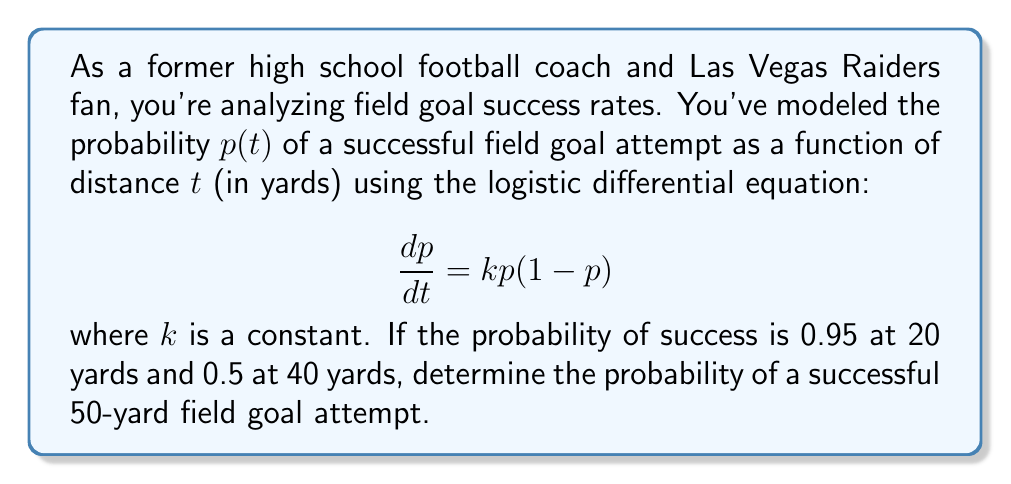Can you solve this math problem? Let's solve this step-by-step:

1) The general solution to the logistic differential equation is:

   $$p(t) = \frac{1}{1 + Ce^{-kt}}$$

2) We need to find $k$ and $C$ using the given conditions:

   At $t=20$, $p(20) = 0.95$
   At $t=40$, $p(40) = 0.5$

3) Using the condition at $t=40$:

   $$0.5 = \frac{1}{1 + Ce^{-40k}}$$

   This simplifies to $Ce^{-40k} = 1$

4) Using the condition at $t=20$:

   $$0.95 = \frac{1}{1 + Ce^{-20k}}$$

   This simplifies to $Ce^{-20k} = \frac{1}{19}$

5) Dividing the equations from steps 3 and 4:

   $$e^{20k} = 19$$

6) Taking the natural log of both sides:

   $$20k = \ln(19)$$

   $$k = \frac{\ln(19)}{20} \approx 0.1461$$

7) Now we can find $C$ using either condition. Let's use $t=40$:

   $$C = e^{40k} = e^{40 \cdot 0.1461} \approx 344.8$$

8) Now we have our complete model:

   $$p(t) = \frac{1}{1 + 344.8e^{-0.1461t}}$$

9) To find the probability at 50 yards, we plug in $t=50$:

   $$p(50) = \frac{1}{1 + 344.8e^{-0.1461 \cdot 50}} \approx 0.2689$$
Answer: 0.2689 or approximately 26.89% 